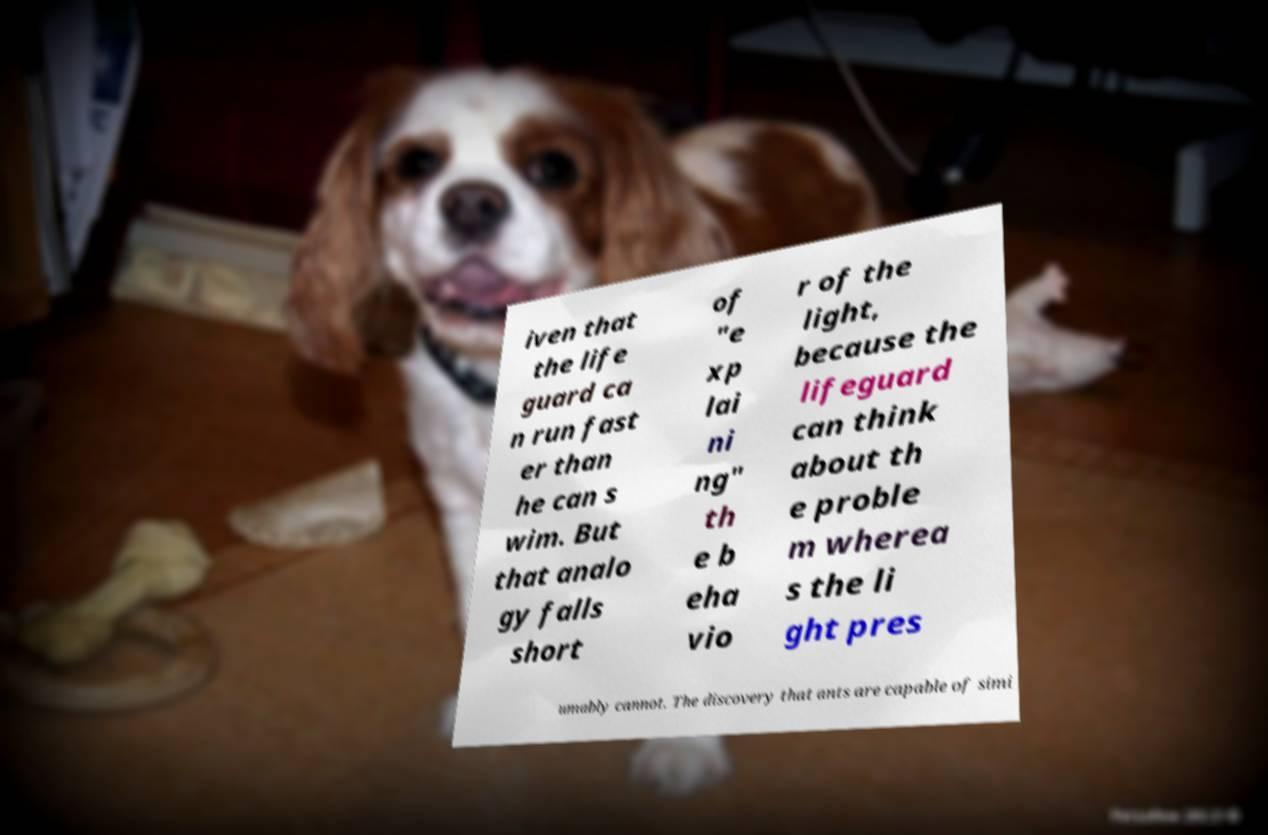What messages or text are displayed in this image? I need them in a readable, typed format. iven that the life guard ca n run fast er than he can s wim. But that analo gy falls short of "e xp lai ni ng" th e b eha vio r of the light, because the lifeguard can think about th e proble m wherea s the li ght pres umably cannot. The discovery that ants are capable of simi 